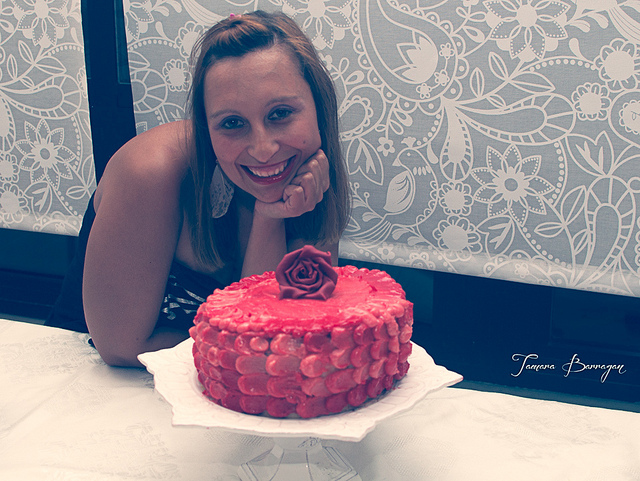Please transcribe the text information in this image. Barragon TAMANA 